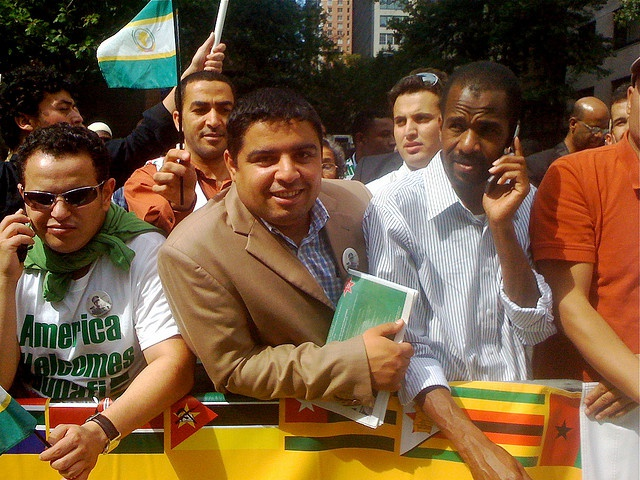Describe the objects in this image and their specific colors. I can see people in black, maroon, brown, and gray tones, people in black, darkgray, lightgray, maroon, and gray tones, people in black, maroon, darkgray, and brown tones, people in black, red, brown, and maroon tones, and people in black, maroon, brown, and tan tones in this image. 